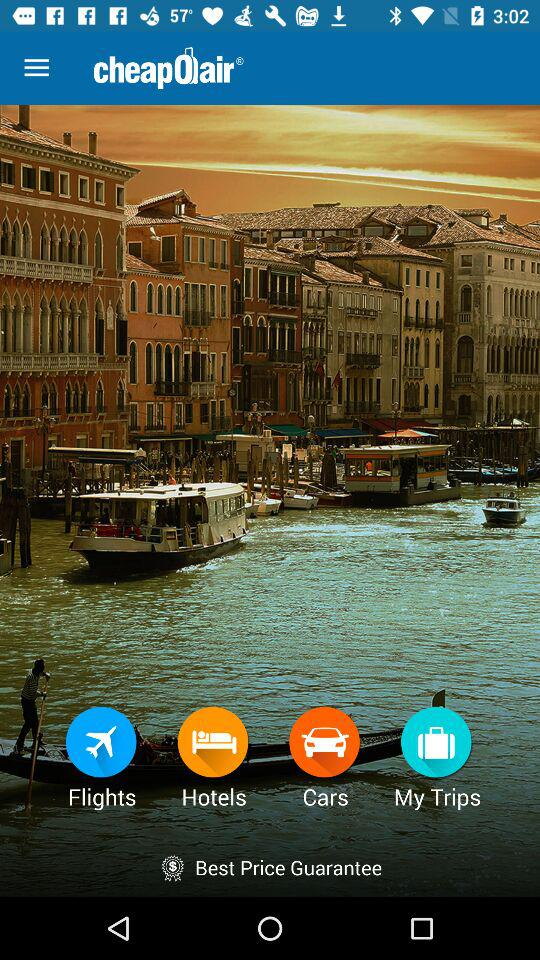What guarantee does the application provide? The application provides the best price guarantee. 